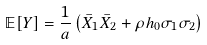<formula> <loc_0><loc_0><loc_500><loc_500>\mathbb { E } [ Y ] = \frac { 1 } { a } \left ( \bar { X } _ { 1 } \bar { X } _ { 2 } + \rho h _ { 0 } \sigma _ { 1 } \sigma _ { 2 } \right )</formula> 